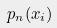<formula> <loc_0><loc_0><loc_500><loc_500>p _ { n } ( x _ { i } )</formula> 